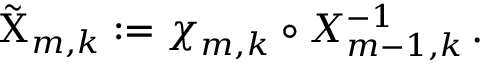Convert formula to latex. <formula><loc_0><loc_0><loc_500><loc_500>\tilde { \chi } _ { m , k } \colon = { \chi } _ { m , k } \circ X _ { m - 1 , k } ^ { - 1 } \, .</formula> 